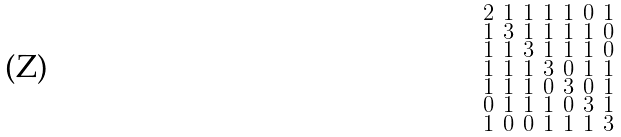<formula> <loc_0><loc_0><loc_500><loc_500>\begin{smallmatrix} 2 & 1 & 1 & 1 & 1 & 0 & 1 \\ 1 & 3 & 1 & 1 & 1 & 1 & 0 \\ 1 & 1 & 3 & 1 & 1 & 1 & 0 \\ 1 & 1 & 1 & 3 & 0 & 1 & 1 \\ 1 & 1 & 1 & 0 & 3 & 0 & 1 \\ 0 & 1 & 1 & 1 & 0 & 3 & 1 \\ 1 & 0 & 0 & 1 & 1 & 1 & 3 \end{smallmatrix}</formula> 